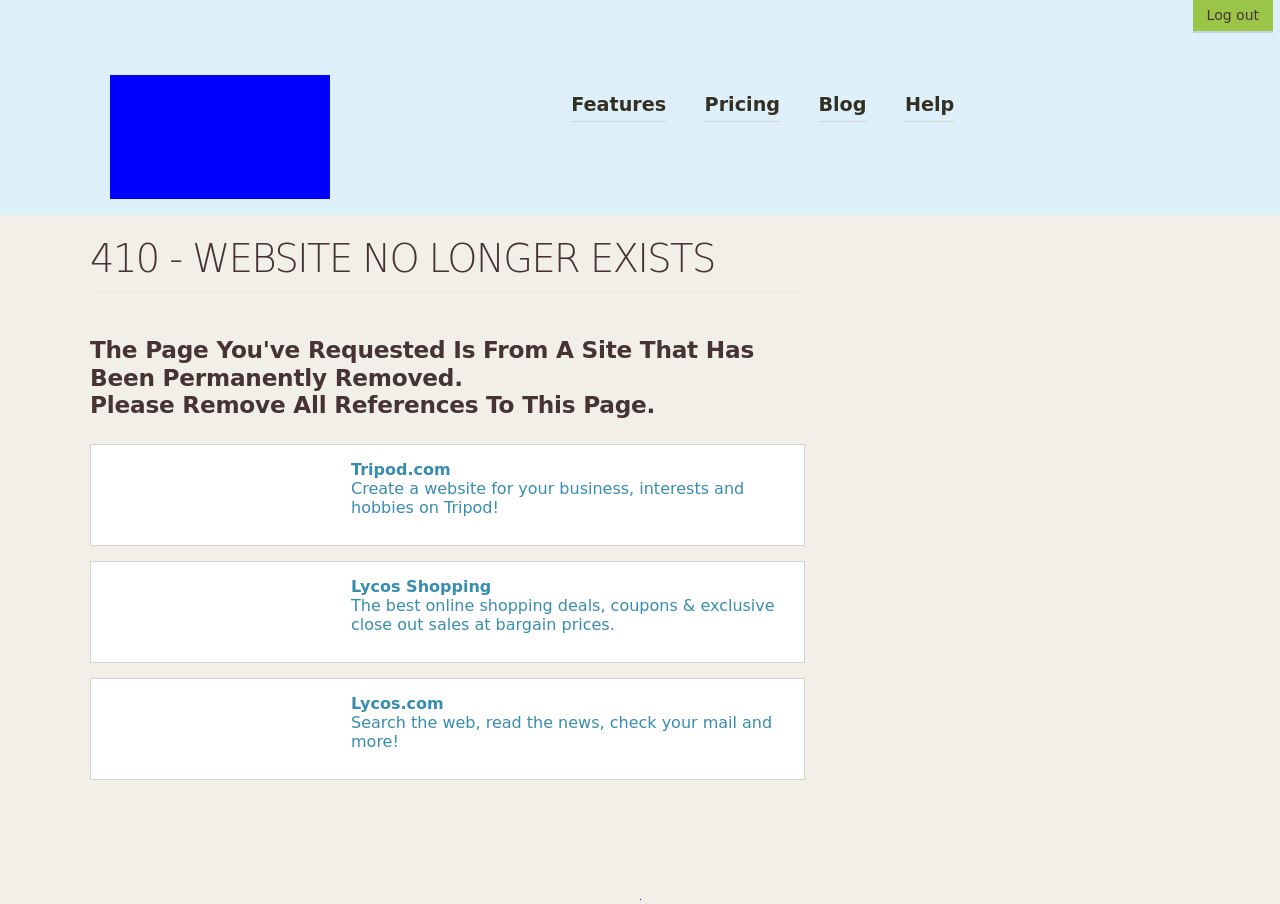Can you tell me more about the companies mentioned on this error page, such as Tripod.com and Lycos.com? Certainly! Tripod.com is a web hosting service that was popular in the late 1990s. It provides tools for building websites and is known for offering free web space, which attracted many users to create personal and hobby sites. Lycos, on the other hand, is one of the oldest search engines, also established in the mid-1990s. Lycos also encompasses a network of email, webhosting, social networking, and entertainment websites. Both companies played significant roles during the early days of the internet, helping users to establish an online presence and search for information. 